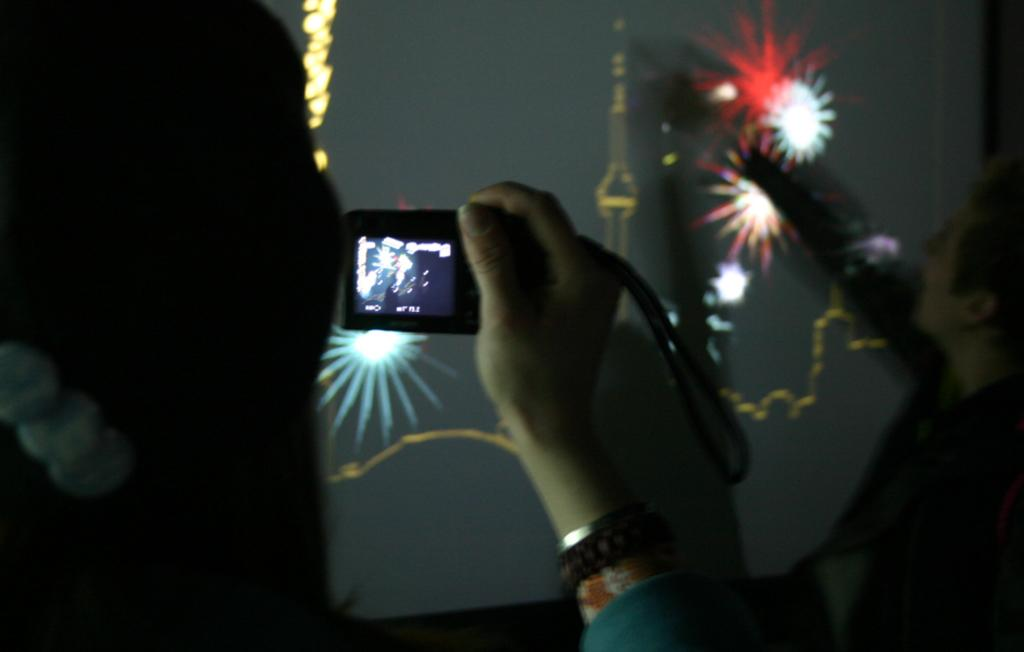What is the main subject of the image? There is a person holding a camera in the center of the image. Can you describe the background of the image? There is a person visible in the background of the image, and there is a screen present in the background as well. What type of plants can be seen growing on the person's face in the image? There are no plants visible on any person's face in the image. What is the person in the background using to hammer nails in the image? There is no hammer or any indication of hammering in the image. 